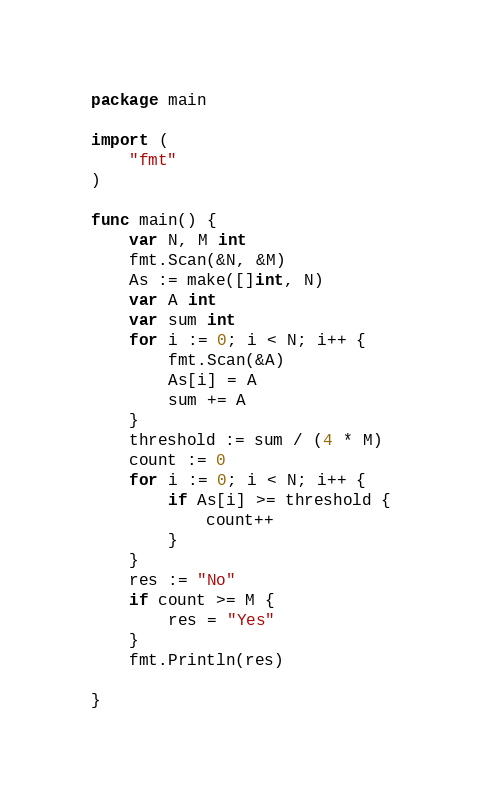Convert code to text. <code><loc_0><loc_0><loc_500><loc_500><_Go_>package main

import (
	"fmt"
)

func main() {
	var N, M int
	fmt.Scan(&N, &M)
	As := make([]int, N)
	var A int
	var sum int
	for i := 0; i < N; i++ {
		fmt.Scan(&A)
		As[i] = A
		sum += A
	}
	threshold := sum / (4 * M)
	count := 0
	for i := 0; i < N; i++ {
		if As[i] >= threshold {
			count++
		}
	}
	res := "No"
	if count >= M {
		res = "Yes"
	}
	fmt.Println(res)

}
</code> 